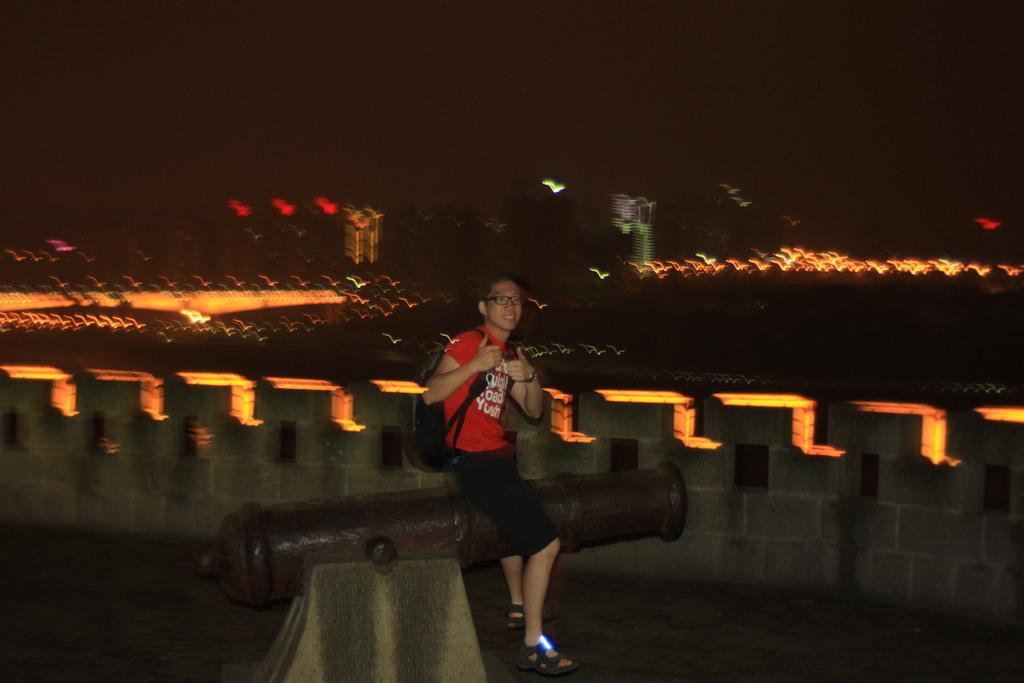What is the main subject of the image? The main subject of the image is a statue of a canon. What is the person in the image doing? The person is sitting on the canon. How is the person dressed in the image? The person is wearing big (possibly large) clothing. What accessories can be seen on the person in the image? The person is wearing a watch and specs (spectacles). What can be seen in the background of the image? There is a wall in the background of the image. What is the source of illumination in the image? There are lights visible in the image. Can you tell me how the person is walking in the image? The person is not walking in the image; they are sitting on the canon. What type of airplane can be seen flying in the image? There is no airplane visible in the image. 